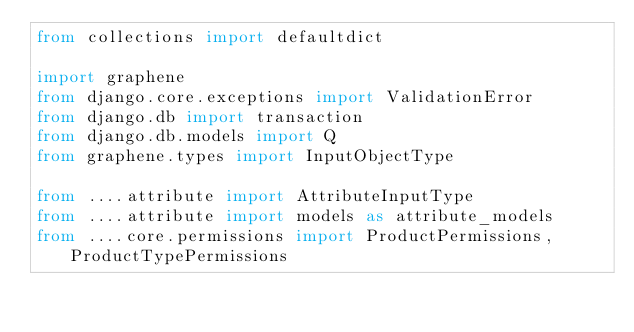Convert code to text. <code><loc_0><loc_0><loc_500><loc_500><_Python_>from collections import defaultdict

import graphene
from django.core.exceptions import ValidationError
from django.db import transaction
from django.db.models import Q
from graphene.types import InputObjectType

from ....attribute import AttributeInputType
from ....attribute import models as attribute_models
from ....core.permissions import ProductPermissions, ProductTypePermissions</code> 